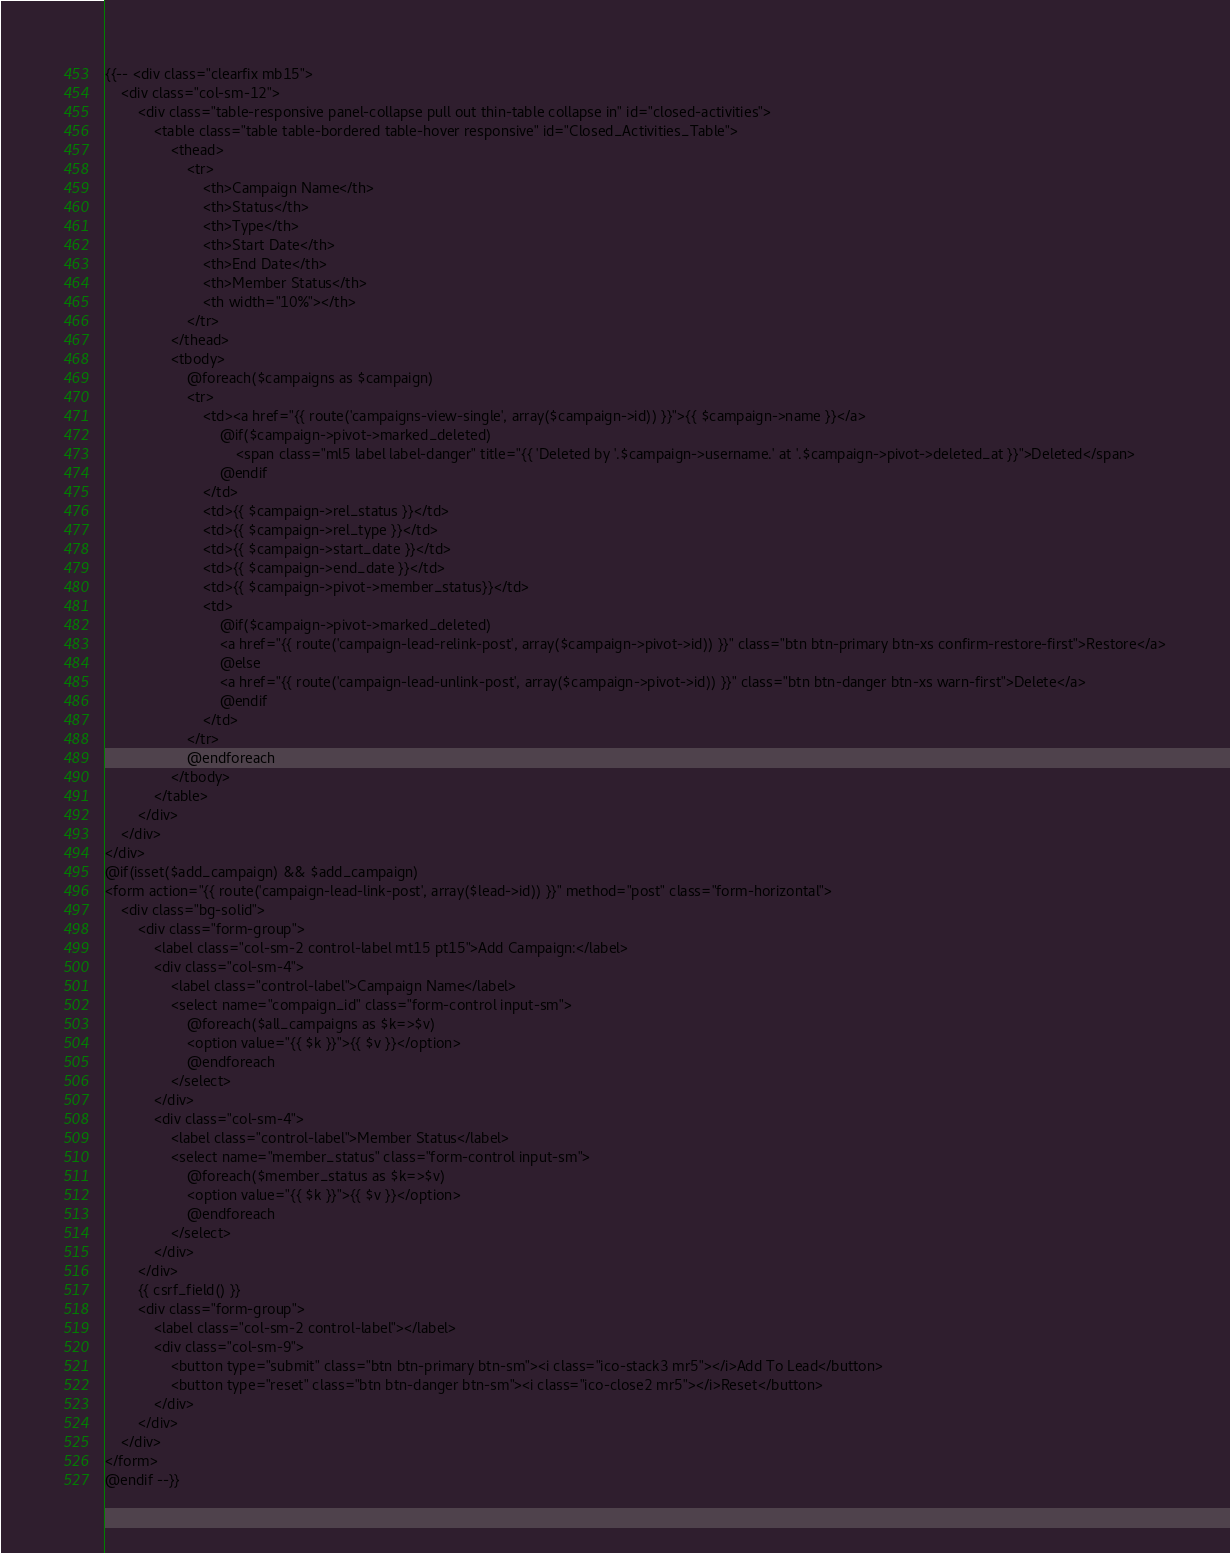Convert code to text. <code><loc_0><loc_0><loc_500><loc_500><_PHP_>{{-- <div class="clearfix mb15">
    <div class="col-sm-12">
        <div class="table-responsive panel-collapse pull out thin-table collapse in" id="closed-activities">
            <table class="table table-bordered table-hover responsive" id="Closed_Activities_Table">
                <thead>
                    <tr>
                        <th>Campaign Name</th>
                        <th>Status</th>
                        <th>Type</th>
                        <th>Start Date</th>
                        <th>End Date</th>
                        <th>Member Status</th>
                        <th width="10%"></th>
                    </tr>
                </thead>
                <tbody>
                    @foreach($campaigns as $campaign)
                    <tr>
                        <td><a href="{{ route('campaigns-view-single', array($campaign->id)) }}">{{ $campaign->name }}</a>
                            @if($campaign->pivot->marked_deleted)
                                <span class="ml5 label label-danger" title="{{ 'Deleted by '.$campaign->username.' at '.$campaign->pivot->deleted_at }}">Deleted</span>
                            @endif
                        </td>
                        <td>{{ $campaign->rel_status }}</td>
                        <td>{{ $campaign->rel_type }}</td>
                        <td>{{ $campaign->start_date }}</td>
                        <td>{{ $campaign->end_date }}</td>
                        <td>{{ $campaign->pivot->member_status}}</td>
                        <td>
                            @if($campaign->pivot->marked_deleted)
                            <a href="{{ route('campaign-lead-relink-post', array($campaign->pivot->id)) }}" class="btn btn-primary btn-xs confirm-restore-first">Restore</a>
                            @else
                            <a href="{{ route('campaign-lead-unlink-post', array($campaign->pivot->id)) }}" class="btn btn-danger btn-xs warn-first">Delete</a>
                            @endif
                        </td>
                    </tr>
                    @endforeach
                </tbody>
            </table>
        </div>
    </div>
</div>
@if(isset($add_campaign) && $add_campaign)
<form action="{{ route('campaign-lead-link-post', array($lead->id)) }}" method="post" class="form-horizontal">
    <div class="bg-solid">
        <div class="form-group">
            <label class="col-sm-2 control-label mt15 pt15">Add Campaign:</label>
            <div class="col-sm-4">
                <label class="control-label">Campaign Name</label>
                <select name="compaign_id" class="form-control input-sm">
                    @foreach($all_campaigns as $k=>$v)
                    <option value="{{ $k }}">{{ $v }}</option>
                    @endforeach
                </select>
            </div>
            <div class="col-sm-4">
                <label class="control-label">Member Status</label>
                <select name="member_status" class="form-control input-sm">
                    @foreach($member_status as $k=>$v)
                    <option value="{{ $k }}">{{ $v }}</option>
                    @endforeach
                </select>
            </div>
        </div>
        {{ csrf_field() }}
        <div class="form-group">
            <label class="col-sm-2 control-label"></label>
            <div class="col-sm-9">
                <button type="submit" class="btn btn-primary btn-sm"><i class="ico-stack3 mr5"></i>Add To Lead</button>
                <button type="reset" class="btn btn-danger btn-sm"><i class="ico-close2 mr5"></i>Reset</button>
            </div>
        </div>
    </div>
</form>
@endif --}}</code> 